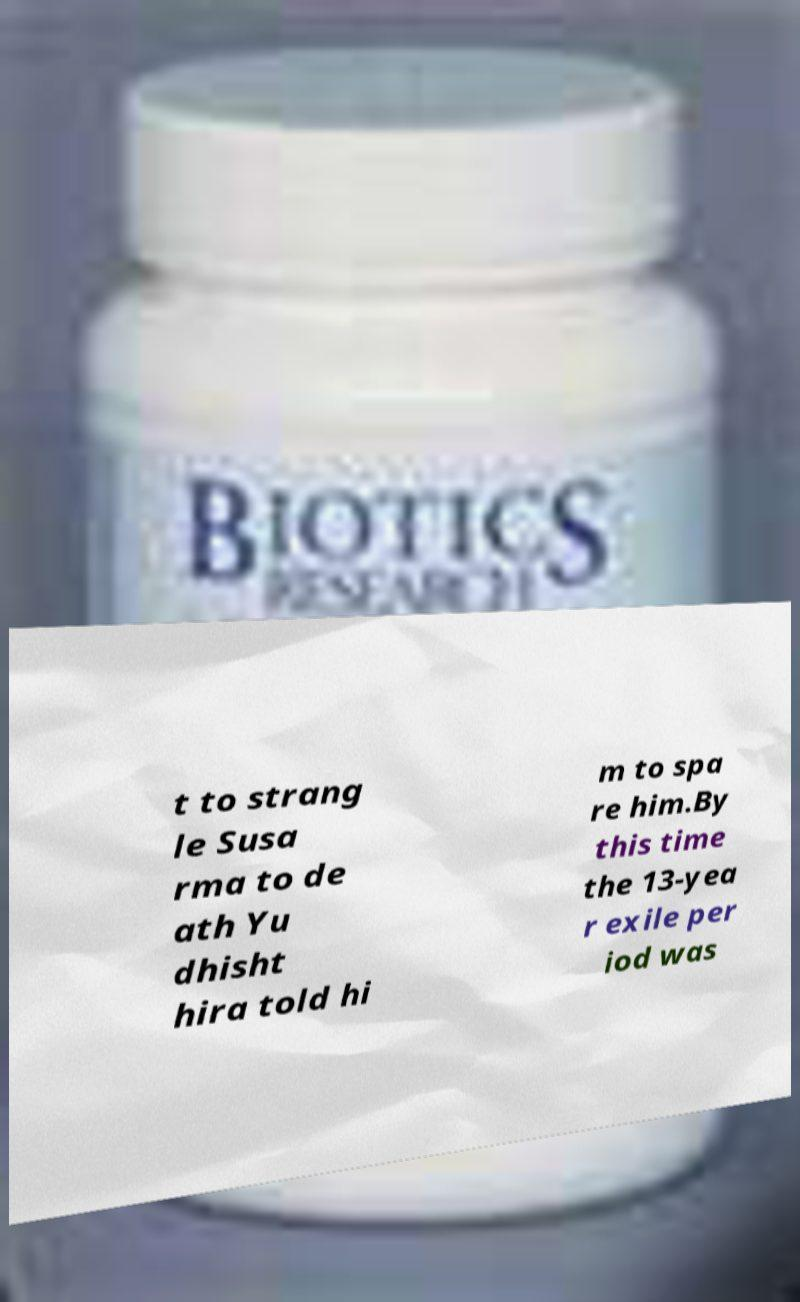Could you assist in decoding the text presented in this image and type it out clearly? t to strang le Susa rma to de ath Yu dhisht hira told hi m to spa re him.By this time the 13-yea r exile per iod was 